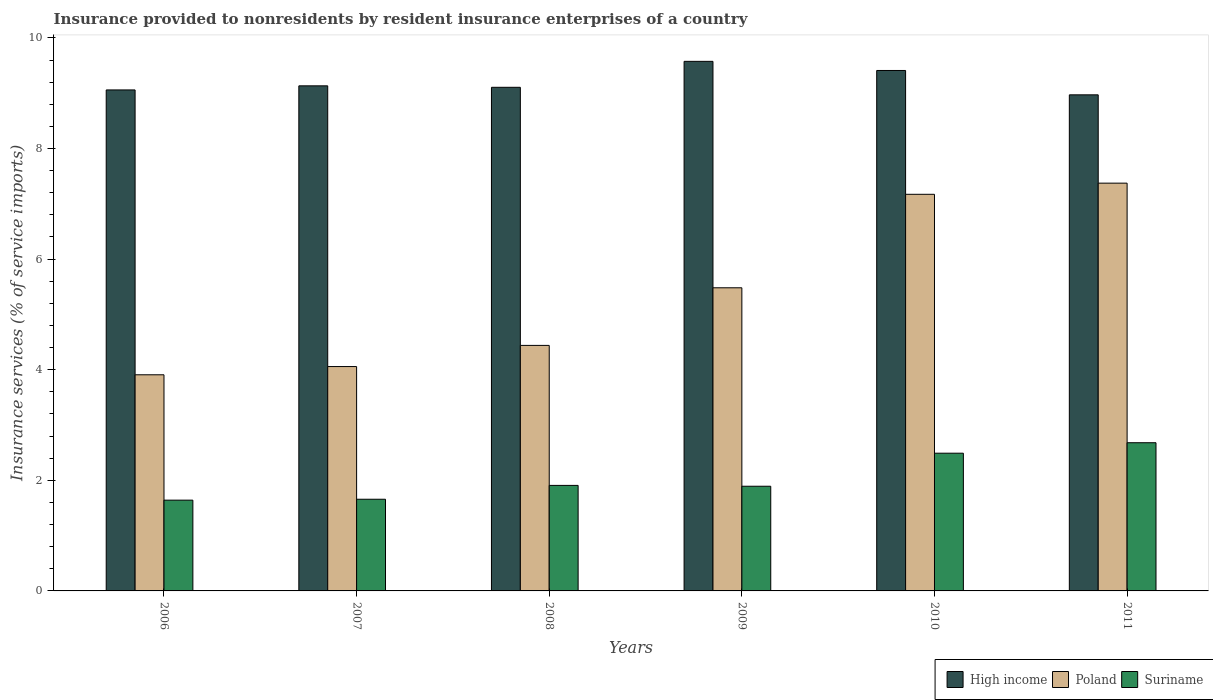How many groups of bars are there?
Ensure brevity in your answer.  6. Are the number of bars on each tick of the X-axis equal?
Your answer should be compact. Yes. How many bars are there on the 4th tick from the left?
Make the answer very short. 3. How many bars are there on the 1st tick from the right?
Keep it short and to the point. 3. What is the insurance provided to nonresidents in Poland in 2011?
Your response must be concise. 7.37. Across all years, what is the maximum insurance provided to nonresidents in Poland?
Provide a succinct answer. 7.37. Across all years, what is the minimum insurance provided to nonresidents in High income?
Your answer should be very brief. 8.97. In which year was the insurance provided to nonresidents in Suriname maximum?
Make the answer very short. 2011. What is the total insurance provided to nonresidents in Suriname in the graph?
Your answer should be compact. 12.27. What is the difference between the insurance provided to nonresidents in Poland in 2008 and that in 2010?
Give a very brief answer. -2.73. What is the difference between the insurance provided to nonresidents in Suriname in 2010 and the insurance provided to nonresidents in High income in 2006?
Your answer should be very brief. -6.57. What is the average insurance provided to nonresidents in Poland per year?
Give a very brief answer. 5.41. In the year 2007, what is the difference between the insurance provided to nonresidents in Suriname and insurance provided to nonresidents in Poland?
Your response must be concise. -2.4. In how many years, is the insurance provided to nonresidents in Suriname greater than 2 %?
Make the answer very short. 2. What is the ratio of the insurance provided to nonresidents in High income in 2008 to that in 2010?
Keep it short and to the point. 0.97. Is the insurance provided to nonresidents in High income in 2006 less than that in 2010?
Make the answer very short. Yes. What is the difference between the highest and the second highest insurance provided to nonresidents in High income?
Make the answer very short. 0.16. What is the difference between the highest and the lowest insurance provided to nonresidents in Poland?
Provide a short and direct response. 3.47. Is the sum of the insurance provided to nonresidents in High income in 2008 and 2011 greater than the maximum insurance provided to nonresidents in Poland across all years?
Your answer should be compact. Yes. What does the 3rd bar from the left in 2008 represents?
Offer a terse response. Suriname. What does the 3rd bar from the right in 2006 represents?
Make the answer very short. High income. Is it the case that in every year, the sum of the insurance provided to nonresidents in Suriname and insurance provided to nonresidents in Poland is greater than the insurance provided to nonresidents in High income?
Provide a succinct answer. No. How many bars are there?
Offer a very short reply. 18. How many years are there in the graph?
Provide a short and direct response. 6. How many legend labels are there?
Provide a succinct answer. 3. How are the legend labels stacked?
Your response must be concise. Horizontal. What is the title of the graph?
Ensure brevity in your answer.  Insurance provided to nonresidents by resident insurance enterprises of a country. Does "West Bank and Gaza" appear as one of the legend labels in the graph?
Give a very brief answer. No. What is the label or title of the Y-axis?
Provide a succinct answer. Insurance services (% of service imports). What is the Insurance services (% of service imports) of High income in 2006?
Keep it short and to the point. 9.06. What is the Insurance services (% of service imports) of Poland in 2006?
Your answer should be very brief. 3.91. What is the Insurance services (% of service imports) in Suriname in 2006?
Offer a terse response. 1.64. What is the Insurance services (% of service imports) in High income in 2007?
Offer a terse response. 9.13. What is the Insurance services (% of service imports) of Poland in 2007?
Provide a short and direct response. 4.06. What is the Insurance services (% of service imports) in Suriname in 2007?
Your answer should be very brief. 1.66. What is the Insurance services (% of service imports) in High income in 2008?
Ensure brevity in your answer.  9.11. What is the Insurance services (% of service imports) of Poland in 2008?
Offer a terse response. 4.44. What is the Insurance services (% of service imports) of Suriname in 2008?
Make the answer very short. 1.91. What is the Insurance services (% of service imports) in High income in 2009?
Ensure brevity in your answer.  9.58. What is the Insurance services (% of service imports) of Poland in 2009?
Offer a terse response. 5.48. What is the Insurance services (% of service imports) of Suriname in 2009?
Offer a very short reply. 1.89. What is the Insurance services (% of service imports) in High income in 2010?
Ensure brevity in your answer.  9.41. What is the Insurance services (% of service imports) in Poland in 2010?
Provide a succinct answer. 7.17. What is the Insurance services (% of service imports) of Suriname in 2010?
Offer a very short reply. 2.49. What is the Insurance services (% of service imports) of High income in 2011?
Make the answer very short. 8.97. What is the Insurance services (% of service imports) of Poland in 2011?
Provide a short and direct response. 7.37. What is the Insurance services (% of service imports) in Suriname in 2011?
Make the answer very short. 2.68. Across all years, what is the maximum Insurance services (% of service imports) in High income?
Your response must be concise. 9.58. Across all years, what is the maximum Insurance services (% of service imports) of Poland?
Ensure brevity in your answer.  7.37. Across all years, what is the maximum Insurance services (% of service imports) in Suriname?
Provide a succinct answer. 2.68. Across all years, what is the minimum Insurance services (% of service imports) in High income?
Your answer should be compact. 8.97. Across all years, what is the minimum Insurance services (% of service imports) of Poland?
Provide a short and direct response. 3.91. Across all years, what is the minimum Insurance services (% of service imports) of Suriname?
Provide a succinct answer. 1.64. What is the total Insurance services (% of service imports) in High income in the graph?
Ensure brevity in your answer.  55.25. What is the total Insurance services (% of service imports) in Poland in the graph?
Ensure brevity in your answer.  32.43. What is the total Insurance services (% of service imports) in Suriname in the graph?
Give a very brief answer. 12.27. What is the difference between the Insurance services (% of service imports) in High income in 2006 and that in 2007?
Provide a succinct answer. -0.07. What is the difference between the Insurance services (% of service imports) in Poland in 2006 and that in 2007?
Provide a short and direct response. -0.15. What is the difference between the Insurance services (% of service imports) in Suriname in 2006 and that in 2007?
Provide a short and direct response. -0.02. What is the difference between the Insurance services (% of service imports) in High income in 2006 and that in 2008?
Your answer should be compact. -0.05. What is the difference between the Insurance services (% of service imports) in Poland in 2006 and that in 2008?
Your answer should be very brief. -0.53. What is the difference between the Insurance services (% of service imports) in Suriname in 2006 and that in 2008?
Your response must be concise. -0.27. What is the difference between the Insurance services (% of service imports) in High income in 2006 and that in 2009?
Your answer should be very brief. -0.52. What is the difference between the Insurance services (% of service imports) of Poland in 2006 and that in 2009?
Your answer should be compact. -1.57. What is the difference between the Insurance services (% of service imports) of Suriname in 2006 and that in 2009?
Make the answer very short. -0.25. What is the difference between the Insurance services (% of service imports) in High income in 2006 and that in 2010?
Give a very brief answer. -0.35. What is the difference between the Insurance services (% of service imports) in Poland in 2006 and that in 2010?
Offer a very short reply. -3.26. What is the difference between the Insurance services (% of service imports) of Suriname in 2006 and that in 2010?
Provide a short and direct response. -0.85. What is the difference between the Insurance services (% of service imports) of High income in 2006 and that in 2011?
Provide a short and direct response. 0.09. What is the difference between the Insurance services (% of service imports) of Poland in 2006 and that in 2011?
Your answer should be very brief. -3.47. What is the difference between the Insurance services (% of service imports) of Suriname in 2006 and that in 2011?
Make the answer very short. -1.04. What is the difference between the Insurance services (% of service imports) in High income in 2007 and that in 2008?
Give a very brief answer. 0.03. What is the difference between the Insurance services (% of service imports) of Poland in 2007 and that in 2008?
Provide a short and direct response. -0.38. What is the difference between the Insurance services (% of service imports) of Suriname in 2007 and that in 2008?
Ensure brevity in your answer.  -0.25. What is the difference between the Insurance services (% of service imports) of High income in 2007 and that in 2009?
Provide a short and direct response. -0.44. What is the difference between the Insurance services (% of service imports) of Poland in 2007 and that in 2009?
Ensure brevity in your answer.  -1.42. What is the difference between the Insurance services (% of service imports) of Suriname in 2007 and that in 2009?
Your response must be concise. -0.23. What is the difference between the Insurance services (% of service imports) in High income in 2007 and that in 2010?
Make the answer very short. -0.28. What is the difference between the Insurance services (% of service imports) in Poland in 2007 and that in 2010?
Provide a short and direct response. -3.11. What is the difference between the Insurance services (% of service imports) in Suriname in 2007 and that in 2010?
Offer a very short reply. -0.83. What is the difference between the Insurance services (% of service imports) in High income in 2007 and that in 2011?
Give a very brief answer. 0.16. What is the difference between the Insurance services (% of service imports) of Poland in 2007 and that in 2011?
Your response must be concise. -3.32. What is the difference between the Insurance services (% of service imports) in Suriname in 2007 and that in 2011?
Offer a very short reply. -1.02. What is the difference between the Insurance services (% of service imports) of High income in 2008 and that in 2009?
Provide a short and direct response. -0.47. What is the difference between the Insurance services (% of service imports) of Poland in 2008 and that in 2009?
Offer a very short reply. -1.04. What is the difference between the Insurance services (% of service imports) of Suriname in 2008 and that in 2009?
Provide a short and direct response. 0.02. What is the difference between the Insurance services (% of service imports) of High income in 2008 and that in 2010?
Your response must be concise. -0.3. What is the difference between the Insurance services (% of service imports) in Poland in 2008 and that in 2010?
Offer a very short reply. -2.73. What is the difference between the Insurance services (% of service imports) of Suriname in 2008 and that in 2010?
Provide a short and direct response. -0.58. What is the difference between the Insurance services (% of service imports) in High income in 2008 and that in 2011?
Give a very brief answer. 0.14. What is the difference between the Insurance services (% of service imports) in Poland in 2008 and that in 2011?
Offer a very short reply. -2.93. What is the difference between the Insurance services (% of service imports) of Suriname in 2008 and that in 2011?
Provide a short and direct response. -0.77. What is the difference between the Insurance services (% of service imports) of High income in 2009 and that in 2010?
Your answer should be very brief. 0.17. What is the difference between the Insurance services (% of service imports) in Poland in 2009 and that in 2010?
Offer a terse response. -1.69. What is the difference between the Insurance services (% of service imports) of Suriname in 2009 and that in 2010?
Ensure brevity in your answer.  -0.6. What is the difference between the Insurance services (% of service imports) in High income in 2009 and that in 2011?
Make the answer very short. 0.61. What is the difference between the Insurance services (% of service imports) of Poland in 2009 and that in 2011?
Ensure brevity in your answer.  -1.89. What is the difference between the Insurance services (% of service imports) of Suriname in 2009 and that in 2011?
Offer a terse response. -0.79. What is the difference between the Insurance services (% of service imports) in High income in 2010 and that in 2011?
Give a very brief answer. 0.44. What is the difference between the Insurance services (% of service imports) of Poland in 2010 and that in 2011?
Your answer should be very brief. -0.2. What is the difference between the Insurance services (% of service imports) in Suriname in 2010 and that in 2011?
Ensure brevity in your answer.  -0.19. What is the difference between the Insurance services (% of service imports) of High income in 2006 and the Insurance services (% of service imports) of Poland in 2007?
Make the answer very short. 5. What is the difference between the Insurance services (% of service imports) of High income in 2006 and the Insurance services (% of service imports) of Suriname in 2007?
Offer a terse response. 7.4. What is the difference between the Insurance services (% of service imports) in Poland in 2006 and the Insurance services (% of service imports) in Suriname in 2007?
Ensure brevity in your answer.  2.25. What is the difference between the Insurance services (% of service imports) in High income in 2006 and the Insurance services (% of service imports) in Poland in 2008?
Offer a terse response. 4.62. What is the difference between the Insurance services (% of service imports) of High income in 2006 and the Insurance services (% of service imports) of Suriname in 2008?
Offer a very short reply. 7.15. What is the difference between the Insurance services (% of service imports) of Poland in 2006 and the Insurance services (% of service imports) of Suriname in 2008?
Provide a succinct answer. 2. What is the difference between the Insurance services (% of service imports) in High income in 2006 and the Insurance services (% of service imports) in Poland in 2009?
Make the answer very short. 3.58. What is the difference between the Insurance services (% of service imports) in High income in 2006 and the Insurance services (% of service imports) in Suriname in 2009?
Offer a terse response. 7.17. What is the difference between the Insurance services (% of service imports) in Poland in 2006 and the Insurance services (% of service imports) in Suriname in 2009?
Give a very brief answer. 2.02. What is the difference between the Insurance services (% of service imports) in High income in 2006 and the Insurance services (% of service imports) in Poland in 2010?
Ensure brevity in your answer.  1.89. What is the difference between the Insurance services (% of service imports) of High income in 2006 and the Insurance services (% of service imports) of Suriname in 2010?
Ensure brevity in your answer.  6.57. What is the difference between the Insurance services (% of service imports) of Poland in 2006 and the Insurance services (% of service imports) of Suriname in 2010?
Your response must be concise. 1.42. What is the difference between the Insurance services (% of service imports) of High income in 2006 and the Insurance services (% of service imports) of Poland in 2011?
Ensure brevity in your answer.  1.69. What is the difference between the Insurance services (% of service imports) of High income in 2006 and the Insurance services (% of service imports) of Suriname in 2011?
Your response must be concise. 6.38. What is the difference between the Insurance services (% of service imports) in Poland in 2006 and the Insurance services (% of service imports) in Suriname in 2011?
Provide a succinct answer. 1.23. What is the difference between the Insurance services (% of service imports) in High income in 2007 and the Insurance services (% of service imports) in Poland in 2008?
Your answer should be very brief. 4.69. What is the difference between the Insurance services (% of service imports) of High income in 2007 and the Insurance services (% of service imports) of Suriname in 2008?
Make the answer very short. 7.22. What is the difference between the Insurance services (% of service imports) of Poland in 2007 and the Insurance services (% of service imports) of Suriname in 2008?
Your response must be concise. 2.15. What is the difference between the Insurance services (% of service imports) of High income in 2007 and the Insurance services (% of service imports) of Poland in 2009?
Provide a short and direct response. 3.65. What is the difference between the Insurance services (% of service imports) in High income in 2007 and the Insurance services (% of service imports) in Suriname in 2009?
Offer a very short reply. 7.24. What is the difference between the Insurance services (% of service imports) in Poland in 2007 and the Insurance services (% of service imports) in Suriname in 2009?
Give a very brief answer. 2.16. What is the difference between the Insurance services (% of service imports) in High income in 2007 and the Insurance services (% of service imports) in Poland in 2010?
Provide a short and direct response. 1.96. What is the difference between the Insurance services (% of service imports) of High income in 2007 and the Insurance services (% of service imports) of Suriname in 2010?
Provide a short and direct response. 6.64. What is the difference between the Insurance services (% of service imports) of Poland in 2007 and the Insurance services (% of service imports) of Suriname in 2010?
Provide a short and direct response. 1.57. What is the difference between the Insurance services (% of service imports) of High income in 2007 and the Insurance services (% of service imports) of Poland in 2011?
Ensure brevity in your answer.  1.76. What is the difference between the Insurance services (% of service imports) in High income in 2007 and the Insurance services (% of service imports) in Suriname in 2011?
Keep it short and to the point. 6.45. What is the difference between the Insurance services (% of service imports) in Poland in 2007 and the Insurance services (% of service imports) in Suriname in 2011?
Provide a short and direct response. 1.38. What is the difference between the Insurance services (% of service imports) of High income in 2008 and the Insurance services (% of service imports) of Poland in 2009?
Keep it short and to the point. 3.63. What is the difference between the Insurance services (% of service imports) of High income in 2008 and the Insurance services (% of service imports) of Suriname in 2009?
Offer a terse response. 7.21. What is the difference between the Insurance services (% of service imports) in Poland in 2008 and the Insurance services (% of service imports) in Suriname in 2009?
Provide a succinct answer. 2.55. What is the difference between the Insurance services (% of service imports) of High income in 2008 and the Insurance services (% of service imports) of Poland in 2010?
Make the answer very short. 1.93. What is the difference between the Insurance services (% of service imports) in High income in 2008 and the Insurance services (% of service imports) in Suriname in 2010?
Provide a succinct answer. 6.62. What is the difference between the Insurance services (% of service imports) of Poland in 2008 and the Insurance services (% of service imports) of Suriname in 2010?
Provide a short and direct response. 1.95. What is the difference between the Insurance services (% of service imports) in High income in 2008 and the Insurance services (% of service imports) in Poland in 2011?
Your answer should be compact. 1.73. What is the difference between the Insurance services (% of service imports) of High income in 2008 and the Insurance services (% of service imports) of Suriname in 2011?
Provide a succinct answer. 6.43. What is the difference between the Insurance services (% of service imports) in Poland in 2008 and the Insurance services (% of service imports) in Suriname in 2011?
Offer a very short reply. 1.76. What is the difference between the Insurance services (% of service imports) in High income in 2009 and the Insurance services (% of service imports) in Poland in 2010?
Keep it short and to the point. 2.4. What is the difference between the Insurance services (% of service imports) of High income in 2009 and the Insurance services (% of service imports) of Suriname in 2010?
Offer a terse response. 7.09. What is the difference between the Insurance services (% of service imports) of Poland in 2009 and the Insurance services (% of service imports) of Suriname in 2010?
Your response must be concise. 2.99. What is the difference between the Insurance services (% of service imports) in High income in 2009 and the Insurance services (% of service imports) in Poland in 2011?
Your answer should be very brief. 2.2. What is the difference between the Insurance services (% of service imports) of High income in 2009 and the Insurance services (% of service imports) of Suriname in 2011?
Ensure brevity in your answer.  6.9. What is the difference between the Insurance services (% of service imports) in Poland in 2009 and the Insurance services (% of service imports) in Suriname in 2011?
Make the answer very short. 2.8. What is the difference between the Insurance services (% of service imports) of High income in 2010 and the Insurance services (% of service imports) of Poland in 2011?
Make the answer very short. 2.04. What is the difference between the Insurance services (% of service imports) of High income in 2010 and the Insurance services (% of service imports) of Suriname in 2011?
Ensure brevity in your answer.  6.73. What is the difference between the Insurance services (% of service imports) of Poland in 2010 and the Insurance services (% of service imports) of Suriname in 2011?
Offer a terse response. 4.49. What is the average Insurance services (% of service imports) of High income per year?
Provide a short and direct response. 9.21. What is the average Insurance services (% of service imports) in Poland per year?
Keep it short and to the point. 5.41. What is the average Insurance services (% of service imports) of Suriname per year?
Keep it short and to the point. 2.04. In the year 2006, what is the difference between the Insurance services (% of service imports) in High income and Insurance services (% of service imports) in Poland?
Offer a terse response. 5.15. In the year 2006, what is the difference between the Insurance services (% of service imports) of High income and Insurance services (% of service imports) of Suriname?
Provide a succinct answer. 7.42. In the year 2006, what is the difference between the Insurance services (% of service imports) of Poland and Insurance services (% of service imports) of Suriname?
Offer a very short reply. 2.27. In the year 2007, what is the difference between the Insurance services (% of service imports) in High income and Insurance services (% of service imports) in Poland?
Ensure brevity in your answer.  5.08. In the year 2007, what is the difference between the Insurance services (% of service imports) of High income and Insurance services (% of service imports) of Suriname?
Your answer should be very brief. 7.48. In the year 2007, what is the difference between the Insurance services (% of service imports) in Poland and Insurance services (% of service imports) in Suriname?
Make the answer very short. 2.4. In the year 2008, what is the difference between the Insurance services (% of service imports) in High income and Insurance services (% of service imports) in Poland?
Ensure brevity in your answer.  4.67. In the year 2008, what is the difference between the Insurance services (% of service imports) in High income and Insurance services (% of service imports) in Suriname?
Your answer should be very brief. 7.2. In the year 2008, what is the difference between the Insurance services (% of service imports) of Poland and Insurance services (% of service imports) of Suriname?
Make the answer very short. 2.53. In the year 2009, what is the difference between the Insurance services (% of service imports) in High income and Insurance services (% of service imports) in Poland?
Your response must be concise. 4.09. In the year 2009, what is the difference between the Insurance services (% of service imports) of High income and Insurance services (% of service imports) of Suriname?
Your answer should be compact. 7.68. In the year 2009, what is the difference between the Insurance services (% of service imports) of Poland and Insurance services (% of service imports) of Suriname?
Offer a terse response. 3.59. In the year 2010, what is the difference between the Insurance services (% of service imports) in High income and Insurance services (% of service imports) in Poland?
Offer a terse response. 2.24. In the year 2010, what is the difference between the Insurance services (% of service imports) of High income and Insurance services (% of service imports) of Suriname?
Provide a succinct answer. 6.92. In the year 2010, what is the difference between the Insurance services (% of service imports) of Poland and Insurance services (% of service imports) of Suriname?
Provide a succinct answer. 4.68. In the year 2011, what is the difference between the Insurance services (% of service imports) in High income and Insurance services (% of service imports) in Poland?
Give a very brief answer. 1.6. In the year 2011, what is the difference between the Insurance services (% of service imports) of High income and Insurance services (% of service imports) of Suriname?
Your answer should be very brief. 6.29. In the year 2011, what is the difference between the Insurance services (% of service imports) in Poland and Insurance services (% of service imports) in Suriname?
Offer a terse response. 4.69. What is the ratio of the Insurance services (% of service imports) in Poland in 2006 to that in 2007?
Make the answer very short. 0.96. What is the ratio of the Insurance services (% of service imports) in Poland in 2006 to that in 2008?
Your answer should be very brief. 0.88. What is the ratio of the Insurance services (% of service imports) in Suriname in 2006 to that in 2008?
Provide a succinct answer. 0.86. What is the ratio of the Insurance services (% of service imports) of High income in 2006 to that in 2009?
Offer a very short reply. 0.95. What is the ratio of the Insurance services (% of service imports) of Poland in 2006 to that in 2009?
Keep it short and to the point. 0.71. What is the ratio of the Insurance services (% of service imports) in Suriname in 2006 to that in 2009?
Provide a short and direct response. 0.87. What is the ratio of the Insurance services (% of service imports) in High income in 2006 to that in 2010?
Keep it short and to the point. 0.96. What is the ratio of the Insurance services (% of service imports) of Poland in 2006 to that in 2010?
Your answer should be very brief. 0.54. What is the ratio of the Insurance services (% of service imports) in Suriname in 2006 to that in 2010?
Provide a short and direct response. 0.66. What is the ratio of the Insurance services (% of service imports) of High income in 2006 to that in 2011?
Your response must be concise. 1.01. What is the ratio of the Insurance services (% of service imports) of Poland in 2006 to that in 2011?
Offer a terse response. 0.53. What is the ratio of the Insurance services (% of service imports) in Suriname in 2006 to that in 2011?
Ensure brevity in your answer.  0.61. What is the ratio of the Insurance services (% of service imports) of Poland in 2007 to that in 2008?
Offer a terse response. 0.91. What is the ratio of the Insurance services (% of service imports) in Suriname in 2007 to that in 2008?
Give a very brief answer. 0.87. What is the ratio of the Insurance services (% of service imports) in High income in 2007 to that in 2009?
Provide a short and direct response. 0.95. What is the ratio of the Insurance services (% of service imports) of Poland in 2007 to that in 2009?
Offer a very short reply. 0.74. What is the ratio of the Insurance services (% of service imports) in Suriname in 2007 to that in 2009?
Provide a short and direct response. 0.88. What is the ratio of the Insurance services (% of service imports) in High income in 2007 to that in 2010?
Offer a very short reply. 0.97. What is the ratio of the Insurance services (% of service imports) of Poland in 2007 to that in 2010?
Give a very brief answer. 0.57. What is the ratio of the Insurance services (% of service imports) of Suriname in 2007 to that in 2010?
Your answer should be very brief. 0.67. What is the ratio of the Insurance services (% of service imports) in High income in 2007 to that in 2011?
Your answer should be very brief. 1.02. What is the ratio of the Insurance services (% of service imports) of Poland in 2007 to that in 2011?
Your response must be concise. 0.55. What is the ratio of the Insurance services (% of service imports) in Suriname in 2007 to that in 2011?
Offer a terse response. 0.62. What is the ratio of the Insurance services (% of service imports) in High income in 2008 to that in 2009?
Ensure brevity in your answer.  0.95. What is the ratio of the Insurance services (% of service imports) in Poland in 2008 to that in 2009?
Offer a terse response. 0.81. What is the ratio of the Insurance services (% of service imports) of High income in 2008 to that in 2010?
Give a very brief answer. 0.97. What is the ratio of the Insurance services (% of service imports) in Poland in 2008 to that in 2010?
Offer a very short reply. 0.62. What is the ratio of the Insurance services (% of service imports) of Suriname in 2008 to that in 2010?
Your answer should be compact. 0.77. What is the ratio of the Insurance services (% of service imports) of High income in 2008 to that in 2011?
Your answer should be very brief. 1.02. What is the ratio of the Insurance services (% of service imports) in Poland in 2008 to that in 2011?
Provide a succinct answer. 0.6. What is the ratio of the Insurance services (% of service imports) of Suriname in 2008 to that in 2011?
Offer a terse response. 0.71. What is the ratio of the Insurance services (% of service imports) of High income in 2009 to that in 2010?
Give a very brief answer. 1.02. What is the ratio of the Insurance services (% of service imports) in Poland in 2009 to that in 2010?
Ensure brevity in your answer.  0.76. What is the ratio of the Insurance services (% of service imports) in Suriname in 2009 to that in 2010?
Provide a short and direct response. 0.76. What is the ratio of the Insurance services (% of service imports) in High income in 2009 to that in 2011?
Provide a succinct answer. 1.07. What is the ratio of the Insurance services (% of service imports) of Poland in 2009 to that in 2011?
Make the answer very short. 0.74. What is the ratio of the Insurance services (% of service imports) of Suriname in 2009 to that in 2011?
Provide a short and direct response. 0.71. What is the ratio of the Insurance services (% of service imports) of High income in 2010 to that in 2011?
Provide a short and direct response. 1.05. What is the ratio of the Insurance services (% of service imports) in Poland in 2010 to that in 2011?
Make the answer very short. 0.97. What is the ratio of the Insurance services (% of service imports) of Suriname in 2010 to that in 2011?
Provide a short and direct response. 0.93. What is the difference between the highest and the second highest Insurance services (% of service imports) in High income?
Ensure brevity in your answer.  0.17. What is the difference between the highest and the second highest Insurance services (% of service imports) of Poland?
Your answer should be compact. 0.2. What is the difference between the highest and the second highest Insurance services (% of service imports) in Suriname?
Make the answer very short. 0.19. What is the difference between the highest and the lowest Insurance services (% of service imports) of High income?
Give a very brief answer. 0.61. What is the difference between the highest and the lowest Insurance services (% of service imports) in Poland?
Provide a succinct answer. 3.47. What is the difference between the highest and the lowest Insurance services (% of service imports) of Suriname?
Keep it short and to the point. 1.04. 